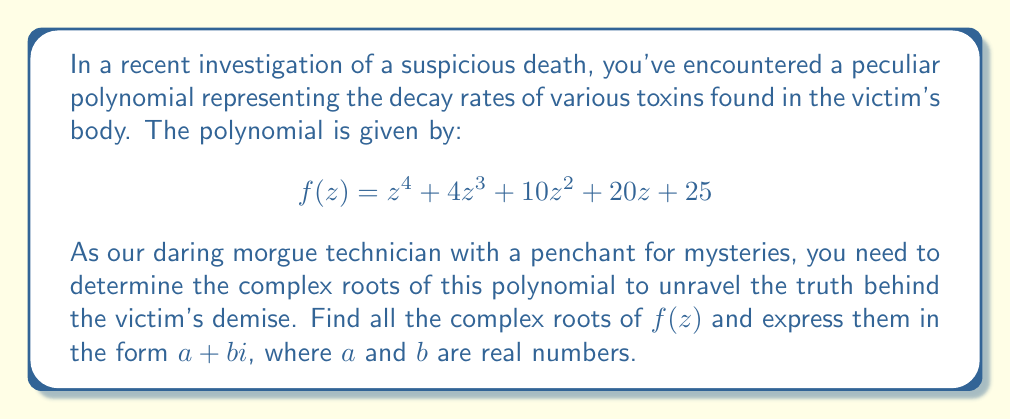Can you solve this math problem? To solve this mystery, we'll use the following steps:

1) First, we notice that the polynomial $f(z)$ can be factored as:

   $$f(z) = (z^2 + 2z + 5)^2$$

2) This is because $(z^2 + 2z + 5)^2 = z^4 + 4z^3 + 10z^2 + 20z + 25$

3) Now, we need to solve the quadratic equation $z^2 + 2z + 5 = 0$

4) We can use the quadratic formula: $z = \frac{-b \pm \sqrt{b^2 - 4ac}}{2a}$

   Where $a = 1$, $b = 2$, and $c = 5$

5) Substituting these values:

   $$z = \frac{-2 \pm \sqrt{2^2 - 4(1)(5)}}{2(1)} = \frac{-2 \pm \sqrt{4 - 20}}{2} = \frac{-2 \pm \sqrt{-16}}{2}$$

6) Simplify:

   $$z = \frac{-2 \pm 4i}{2} = -1 \pm 2i$$

7) Therefore, the two complex roots are:
   
   $z_1 = -1 + 2i$ and $z_2 = -1 - 2i$

8) Since the original polynomial is $(z^2 + 2z + 5)^2$, each of these roots appears twice.

Thus, we have solved our toxic mystery!
Answer: The complex roots of the polynomial are:

$z_1 = -1 + 2i$ (multiplicity 2)
$z_2 = -1 - 2i$ (multiplicity 2) 